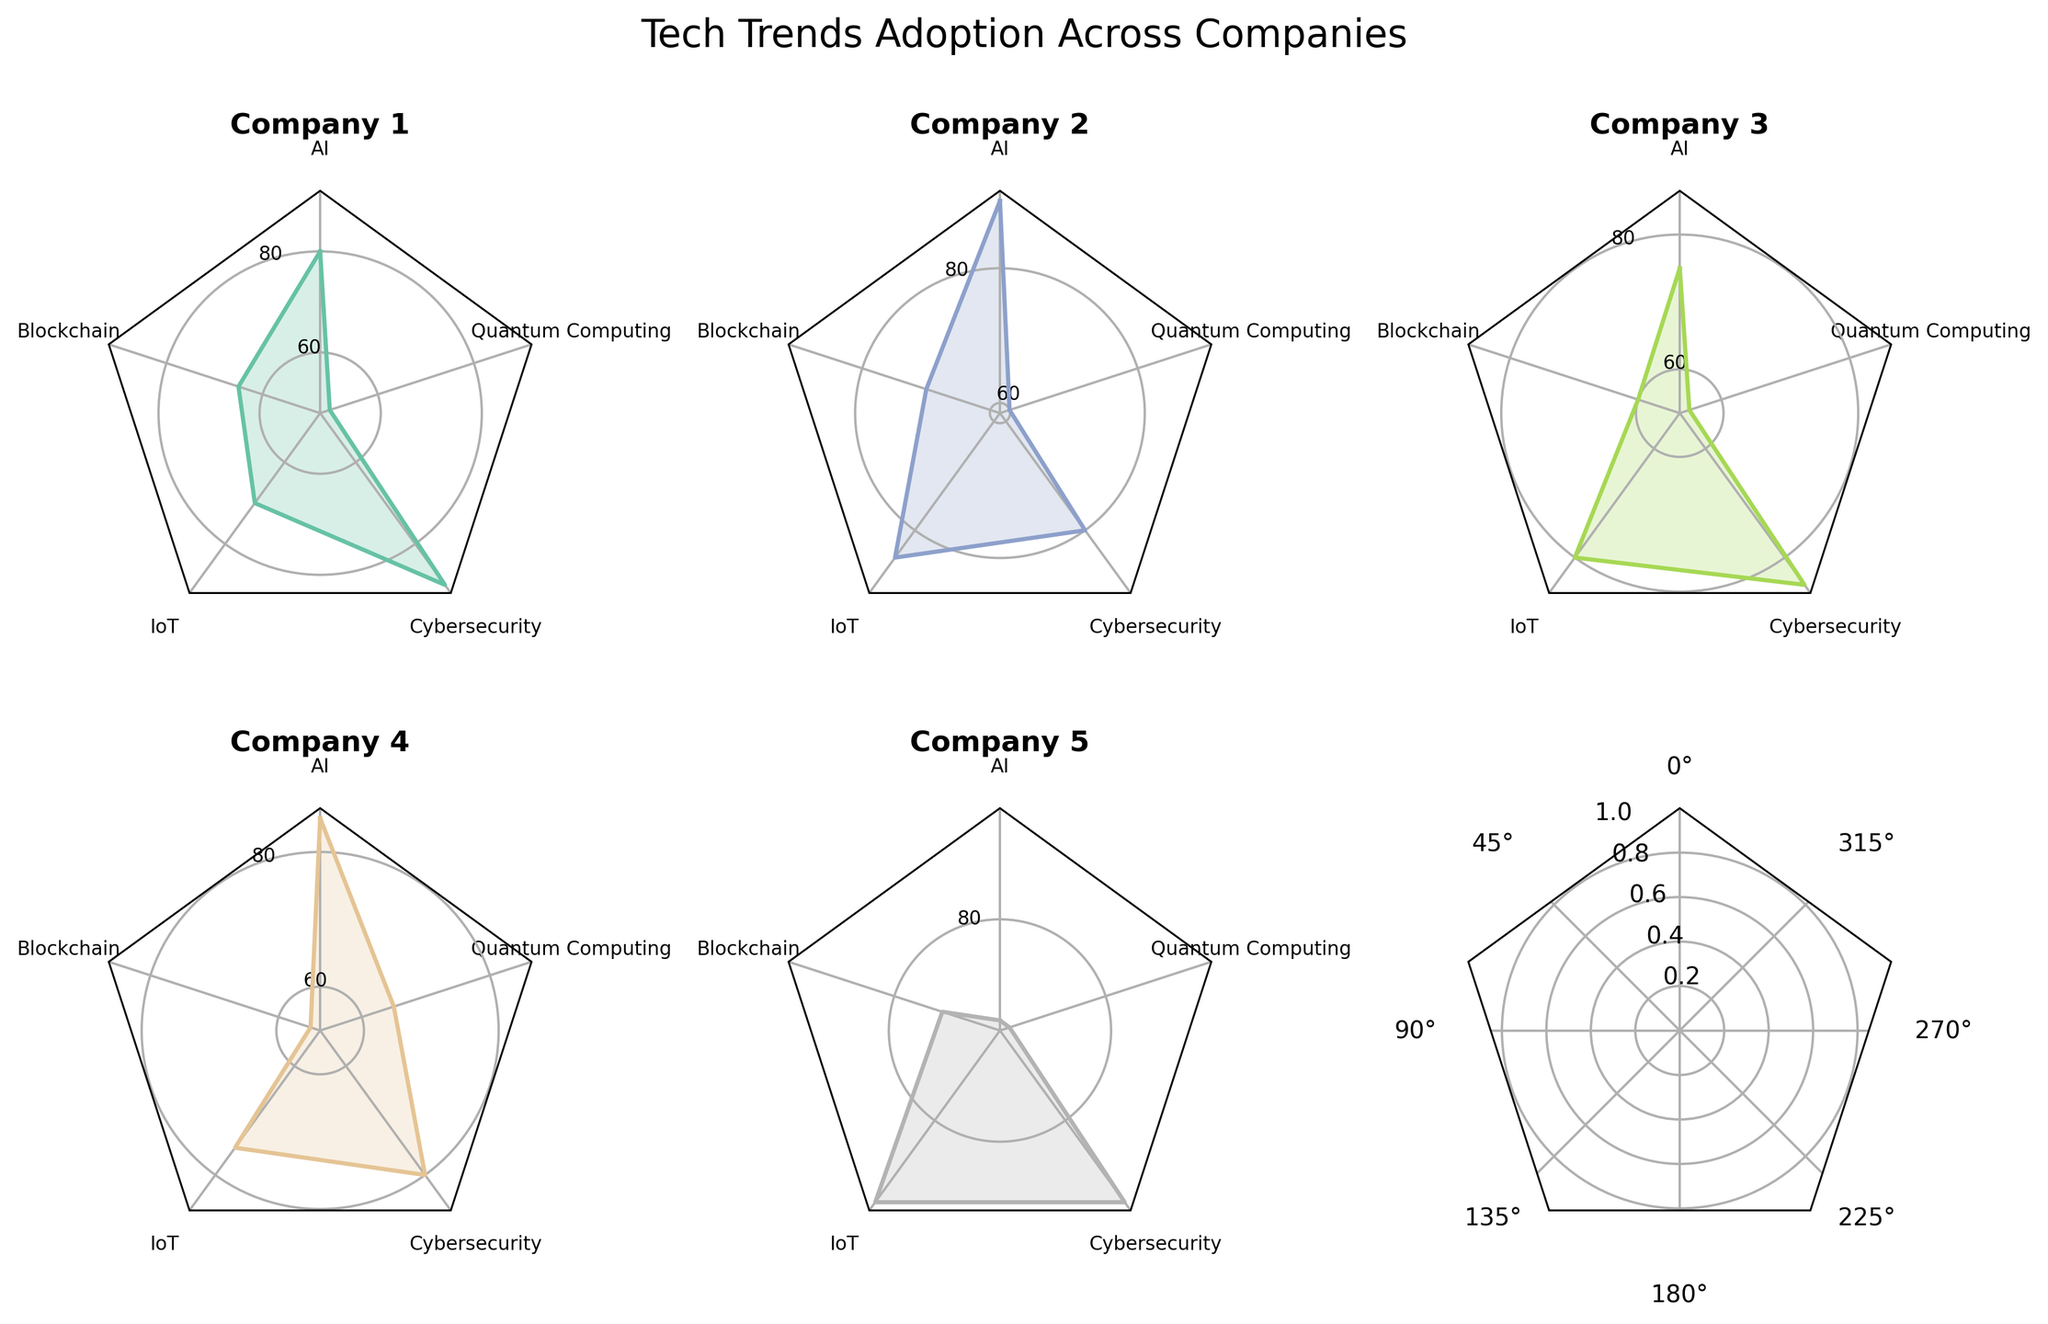What is the title of the figure? The title is typically placed at the top-center of the figure in a larger font size, and it provides a summary of what the figure represents.
Answer: Tech Trends Adoption Across Companies Which company has the highest adoption rate for AI? By looking at the segment corresponding to AI for each company, we can compare the values. Company 2 has the highest value in this segment.
Answer: Company 2 What is the average adoption rate for IoT across all companies? We sum the IoT adoption rates: 70 + 85 + 80 + 75 + 90 = 400. Then, we divide by the number of companies: 400 / 5 = 80.
Answer: 80 Which trend is adopted the least by Company 3? By comparing all the segments for Company 3, we see the lowest value is for Quantum Computing with an adoption rate of 55.
Answer: Quantum Computing Which company has the smallest difference between its highest and lowest adoption rates? We calculate the difference between the highest and lowest values for each company: Company 1 is 90-50=40, Company 2 is 90-60=30, Company 3 is 85-55=30, Company 4 is 85-55=30, and Company 5 is 90-70=20. Company 5 has the smallest difference.
Answer: Company 5 How does the adoption rate of Cybersecurity compare between Company 1 and Company 4? Company 1 has a Cybersecurity rate of 90, while Company 4's rate is 80. Therefore, Company 1 has a higher adoption rate for Cybersecurity than Company 4.
Answer: Company 1 has a higher rate Which company shows the most consistent adoption rates across all trends? Consistency can be determined by the smallest range (difference between highest and lowest values). As previously calculated, the smallest range is 20 for Company 5.
Answer: Company 5 What is the average adoption rate for Quantum Computing across all companies? We sum the Quantum Computing adoption rates: 50 + 60 + 55 + 65 + 70 = 300. Then, we divide by the number of companies: 300 / 5 = 60.
Answer: 60 Which trend shows the largest variation in adoption rates across companies? By comparing the range in values for each technology: AI (90-70=20), Blockchain (75-55=20), IoT (90-70=20), Cybersecurity (90-80=10), Quantum Computing (70-50=20). Four technologies have the largest variation of 20, and the rest have smaller ranges.
Answer: AI, Blockchain, IoT, Quantum Computing (tied) 